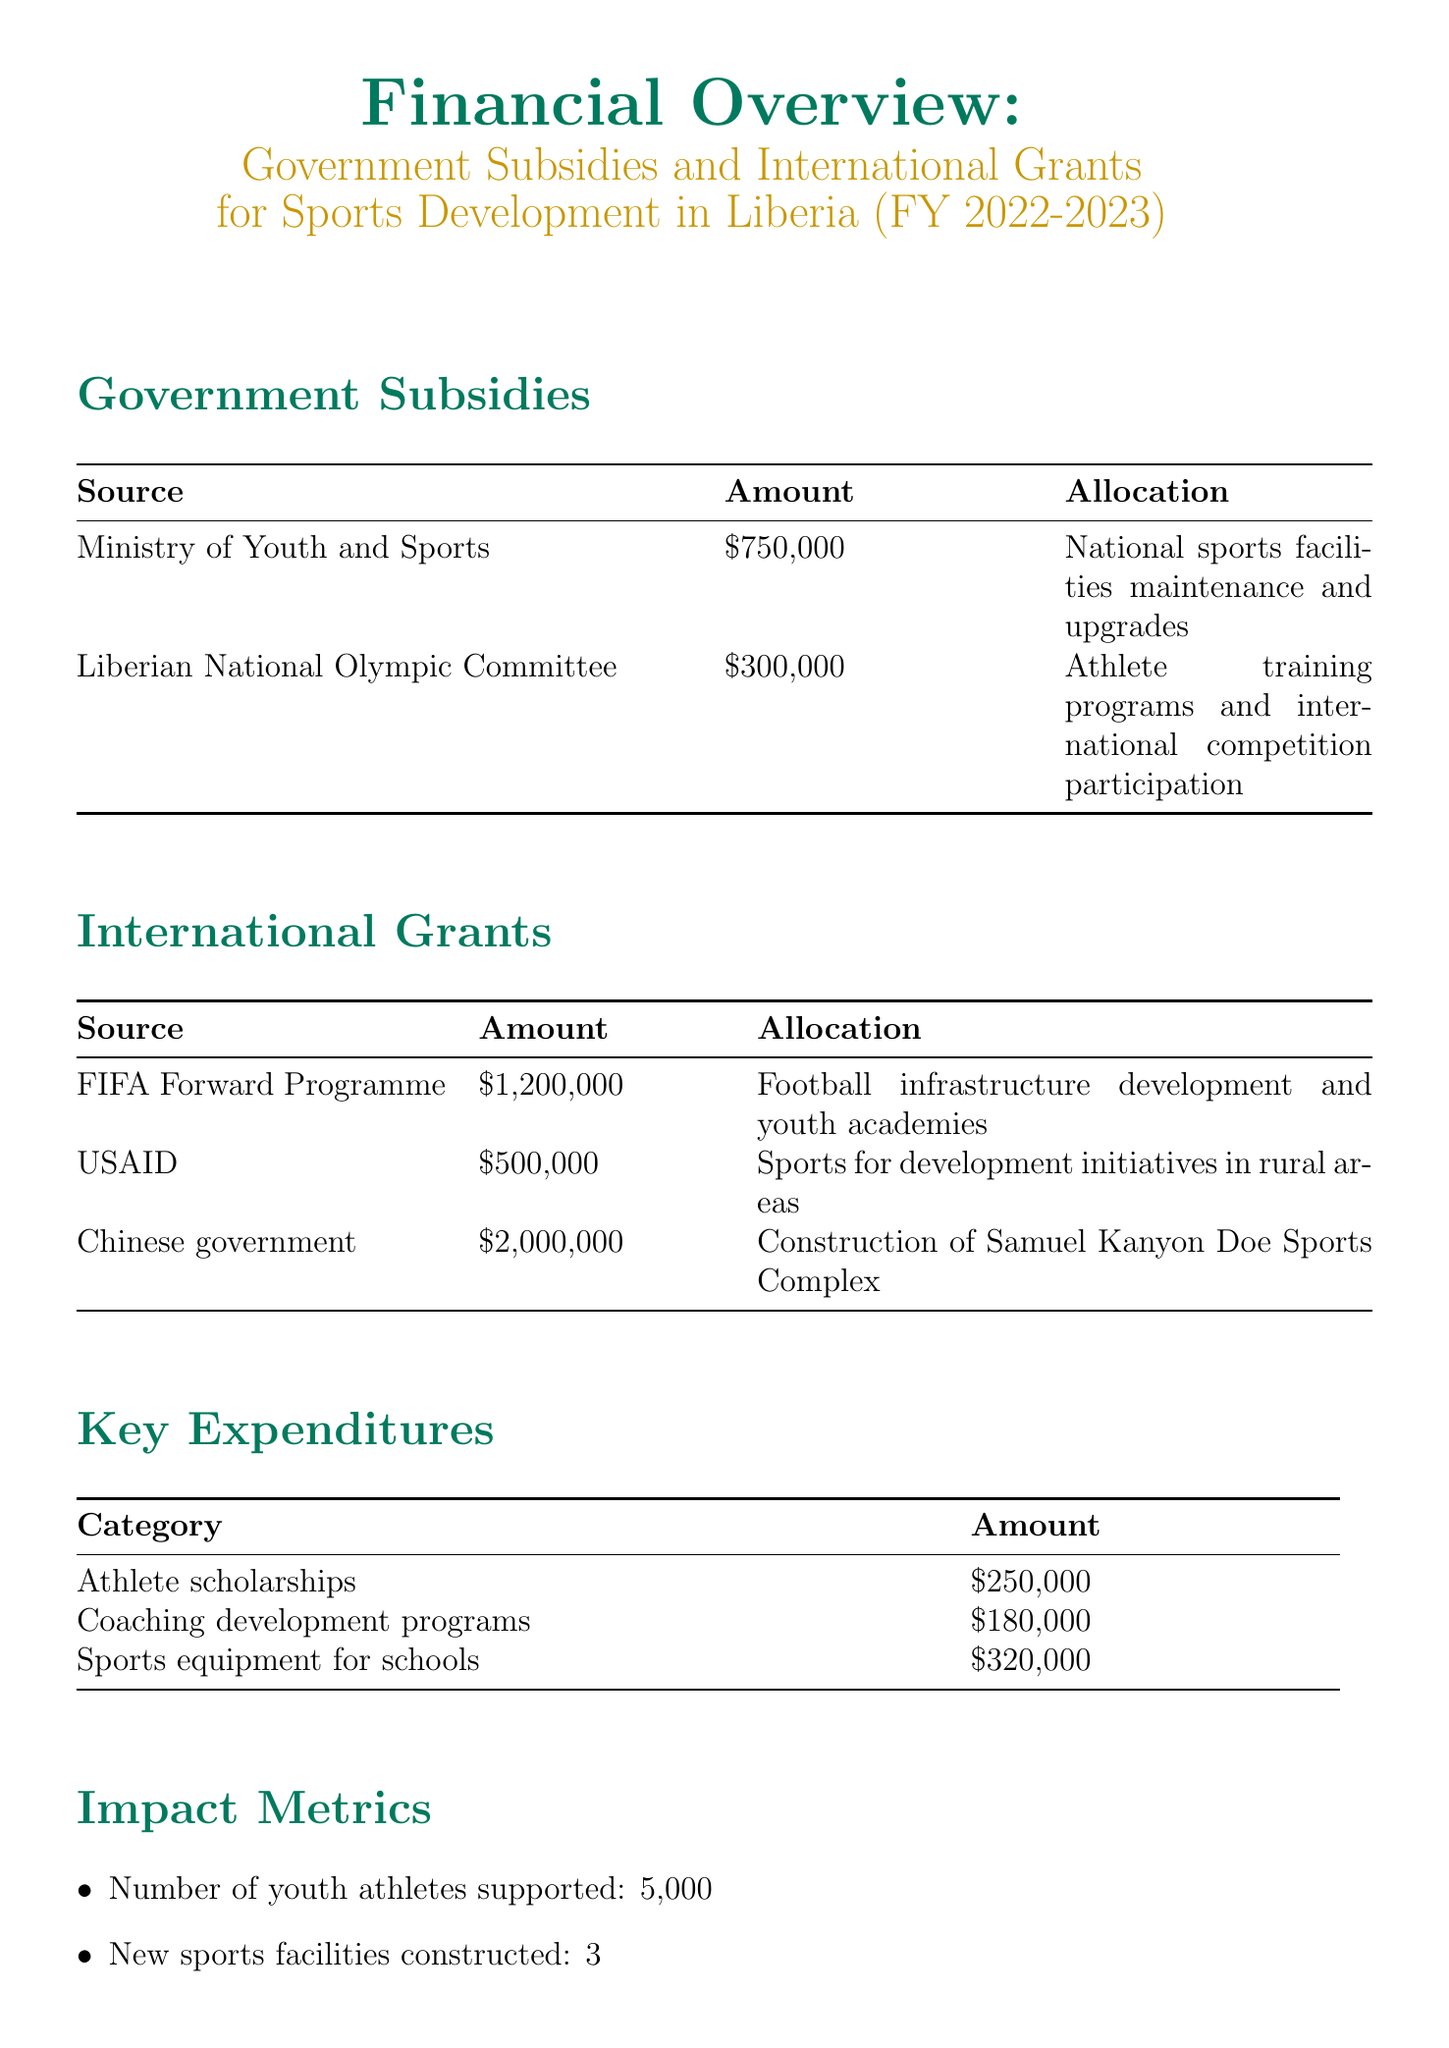What is the total amount of government subsidies? The total amount of government subsidies is the sum of the amounts listed under government subsidies, which is $750,000 + $300,000 = $1,050,000.
Answer: $1,050,000 How many international grants are listed in the report? The report lists three sources of international grants.
Answer: 3 What is the allocation for the China government grant? The allocation for the Chinese government grant is specifically stated in the document.
Answer: Construction of Samuel Kanyon Doe Sports Complex What is the amount allocated for coaching development programs? The allocation for coaching development programs is explicitly mentioned in the key expenditures section.
Answer: $180,000 How many youth athletes were supported according to the impact metrics? The number of youth athletes supported is provided in the impact metrics section of the document.
Answer: 5,000 Which international grant has the highest amount? The highest amount among international grants can be found by comparing the amounts listed.
Answer: Chinese government What is one of the challenges mentioned for future goals? A challenge is listed explicitly, requiring readers to identify one stated goal in the document.
Answer: Increasing private sector involvement in sports funding What was the amount allocated for sports equipment for schools? This amount is specified in the key expenditures section of the report.
Answer: $320,000 How many new sports facilities were constructed according to the impact metrics? The report provides a precise number in the impact metrics section referring to new facilities.
Answer: 3 